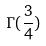<formula> <loc_0><loc_0><loc_500><loc_500>\Gamma ( \frac { 3 } { 4 } )</formula> 